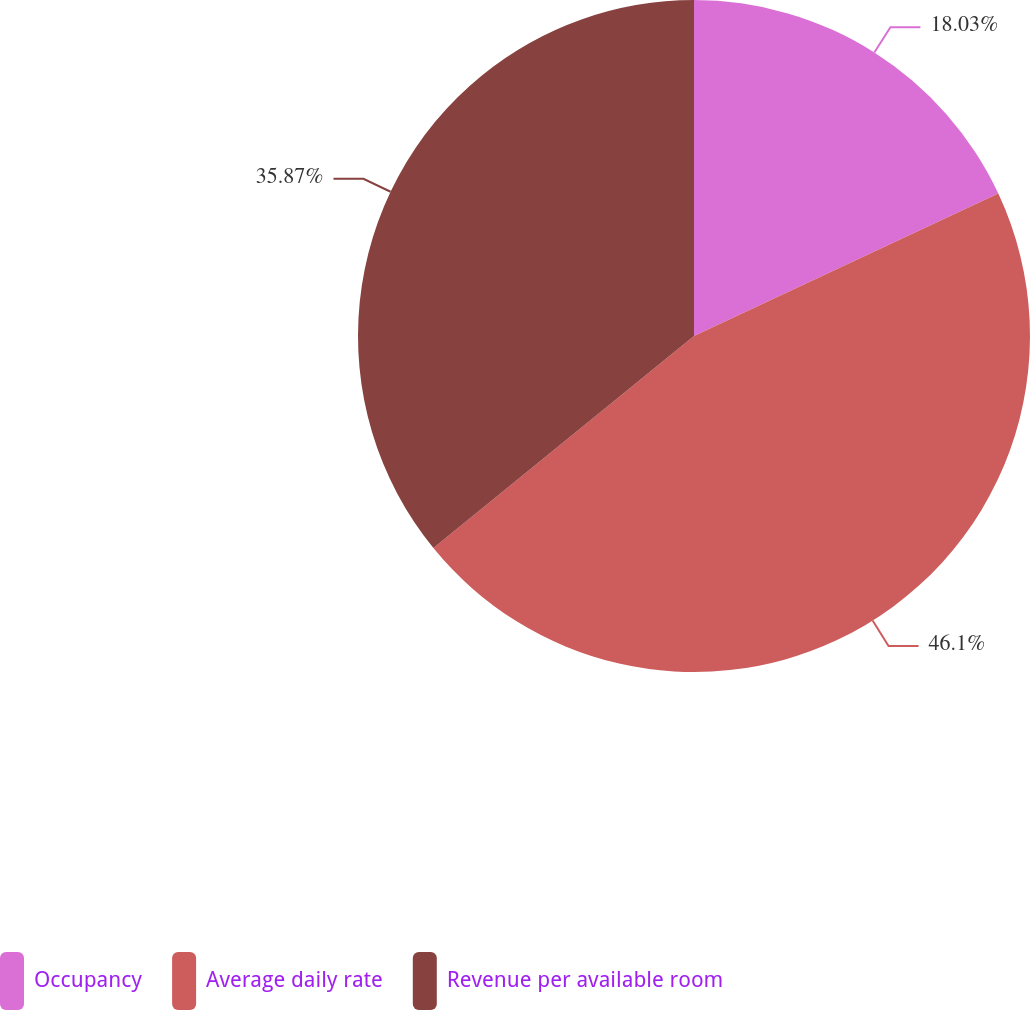Convert chart to OTSL. <chart><loc_0><loc_0><loc_500><loc_500><pie_chart><fcel>Occupancy<fcel>Average daily rate<fcel>Revenue per available room<nl><fcel>18.03%<fcel>46.09%<fcel>35.87%<nl></chart> 